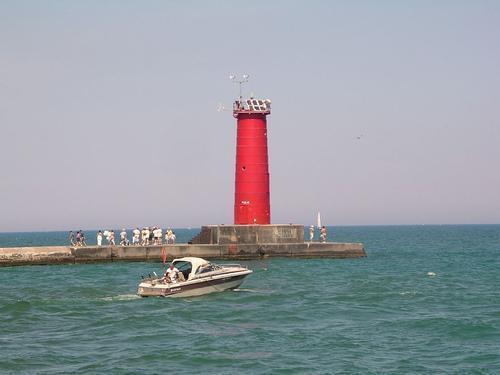What purpose does the red tower serve?
Pick the correct solution from the four options below to address the question.
Options: Toll taking, aquarium, warning ships, prison. Warning ships. How did the people standing near the lighthouse structure arrive here?
Choose the right answer from the provided options to respond to the question.
Options: Uber, walking, by boat, lyft. Walking. 